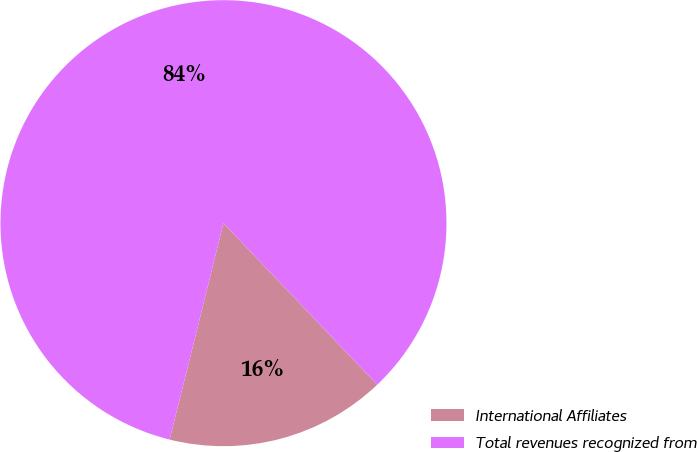Convert chart to OTSL. <chart><loc_0><loc_0><loc_500><loc_500><pie_chart><fcel>International Affiliates<fcel>Total revenues recognized from<nl><fcel>15.99%<fcel>84.01%<nl></chart> 